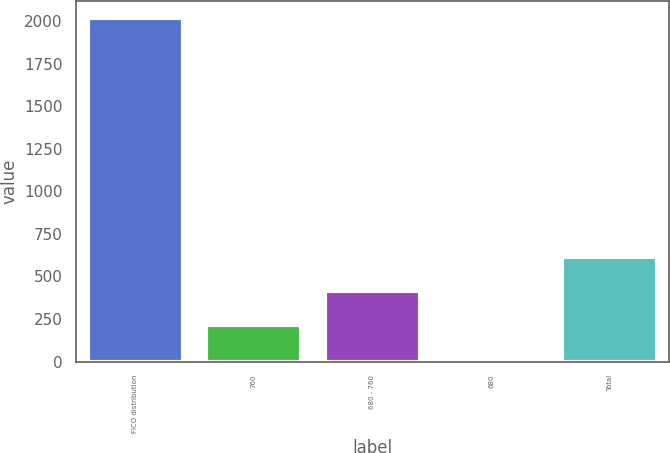Convert chart to OTSL. <chart><loc_0><loc_0><loc_500><loc_500><bar_chart><fcel>FICO distribution<fcel>760<fcel>680 - 760<fcel>680<fcel>Total<nl><fcel>2016<fcel>215.1<fcel>415.2<fcel>15<fcel>615.3<nl></chart> 